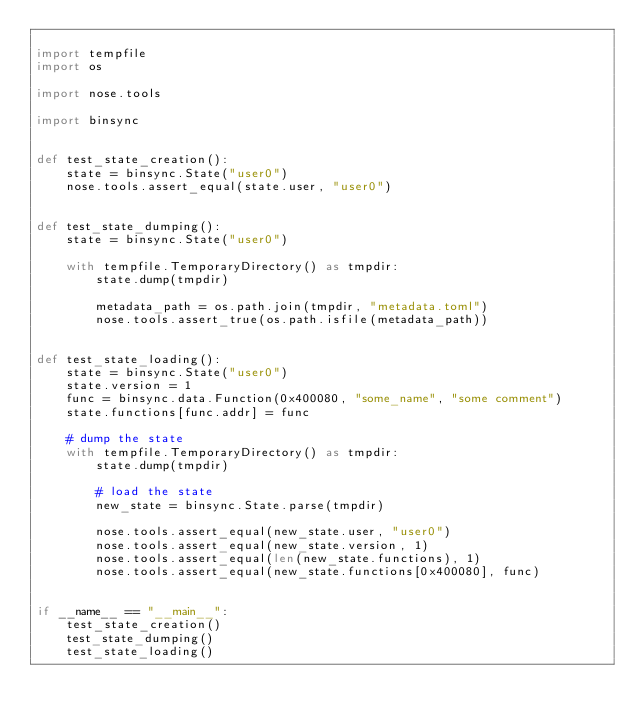Convert code to text. <code><loc_0><loc_0><loc_500><loc_500><_Python_>
import tempfile
import os

import nose.tools

import binsync


def test_state_creation():
    state = binsync.State("user0")
    nose.tools.assert_equal(state.user, "user0")


def test_state_dumping():
    state = binsync.State("user0")

    with tempfile.TemporaryDirectory() as tmpdir:
        state.dump(tmpdir)

        metadata_path = os.path.join(tmpdir, "metadata.toml")
        nose.tools.assert_true(os.path.isfile(metadata_path))


def test_state_loading():
    state = binsync.State("user0")
    state.version = 1
    func = binsync.data.Function(0x400080, "some_name", "some comment")
    state.functions[func.addr] = func

    # dump the state
    with tempfile.TemporaryDirectory() as tmpdir:
        state.dump(tmpdir)

        # load the state
        new_state = binsync.State.parse(tmpdir)

        nose.tools.assert_equal(new_state.user, "user0")
        nose.tools.assert_equal(new_state.version, 1)
        nose.tools.assert_equal(len(new_state.functions), 1)
        nose.tools.assert_equal(new_state.functions[0x400080], func)


if __name__ == "__main__":
    test_state_creation()
    test_state_dumping()
    test_state_loading()
</code> 